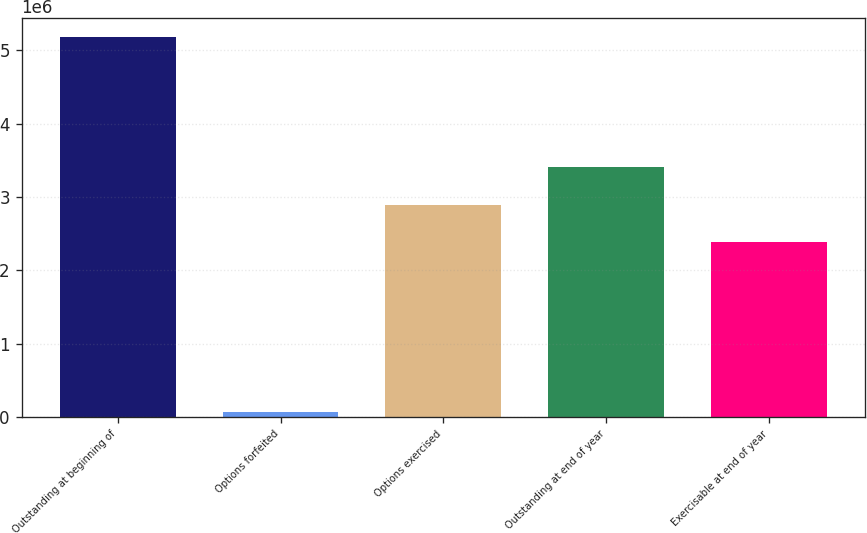Convert chart to OTSL. <chart><loc_0><loc_0><loc_500><loc_500><bar_chart><fcel>Outstanding at beginning of<fcel>Options forfeited<fcel>Options exercised<fcel>Outstanding at end of year<fcel>Exercisable at end of year<nl><fcel>5.18058e+06<fcel>65190<fcel>2.89425e+06<fcel>3.40579e+06<fcel>2.38271e+06<nl></chart> 